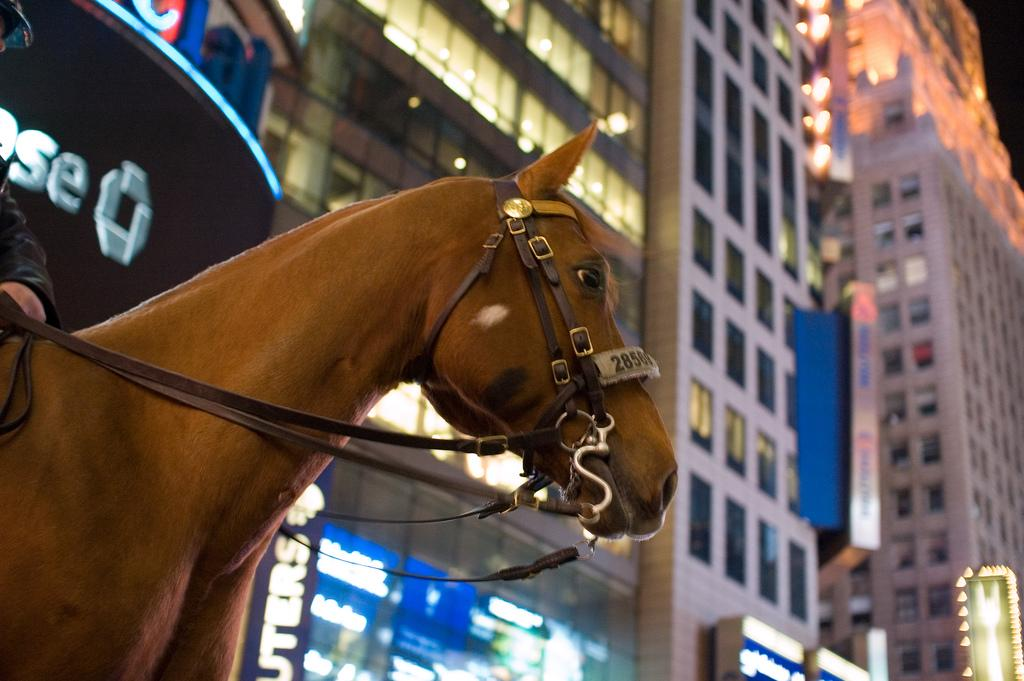What is the main subject of the image? There is a person riding a horse in the image. Where is the person riding the horse located in the image? The person is located in the bottom left side of the image. What can be seen in the background of the image? There are buildings visible behind the horse. What type of cap is the horse wearing in the image? There is no cap present on the horse in the image. What war is depicted in the image? There is no war depicted in the image; it features a person riding a horse with buildings in the background. 